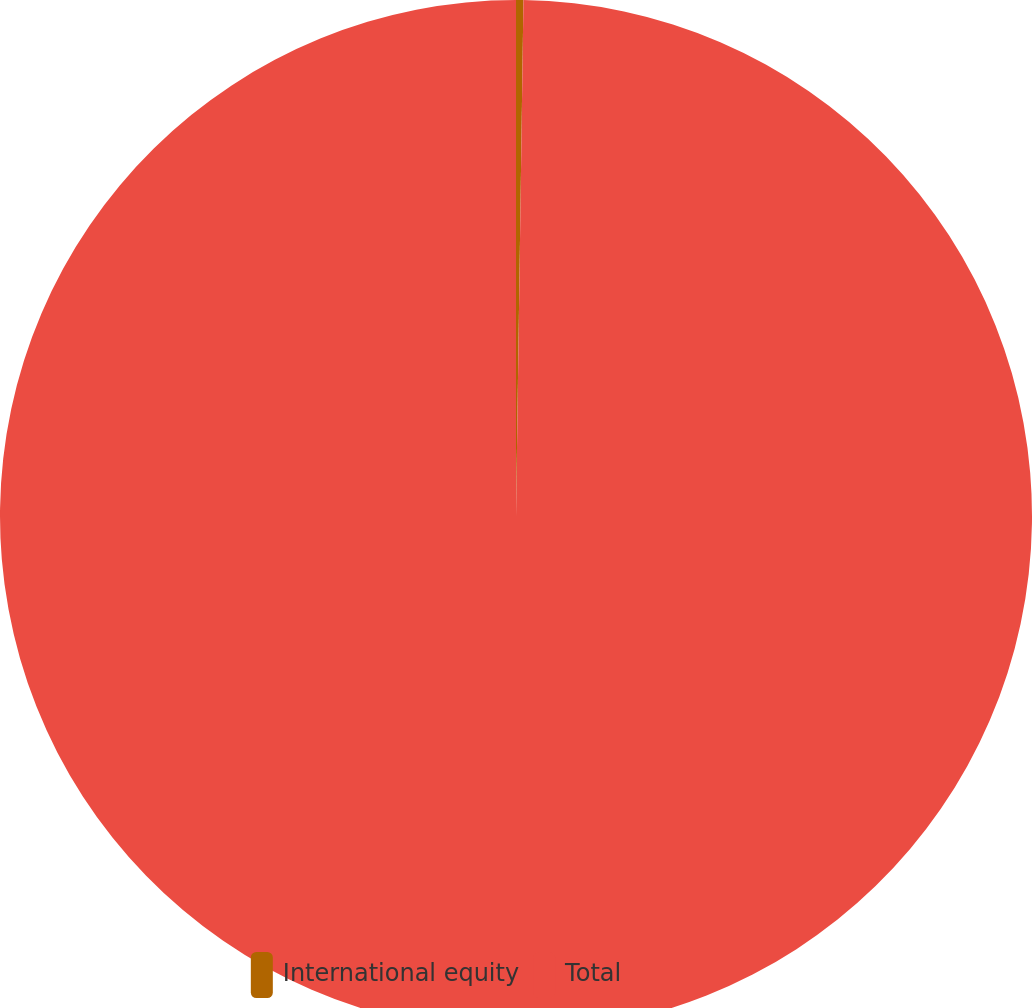<chart> <loc_0><loc_0><loc_500><loc_500><pie_chart><fcel>International equity<fcel>Total<nl><fcel>0.23%<fcel>99.77%<nl></chart> 